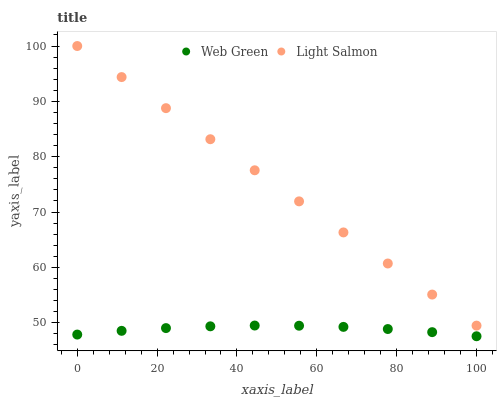Does Web Green have the minimum area under the curve?
Answer yes or no. Yes. Does Light Salmon have the maximum area under the curve?
Answer yes or no. Yes. Does Web Green have the maximum area under the curve?
Answer yes or no. No. Is Light Salmon the smoothest?
Answer yes or no. Yes. Is Web Green the roughest?
Answer yes or no. Yes. Is Web Green the smoothest?
Answer yes or no. No. Does Web Green have the lowest value?
Answer yes or no. Yes. Does Light Salmon have the highest value?
Answer yes or no. Yes. Does Web Green have the highest value?
Answer yes or no. No. Is Web Green less than Light Salmon?
Answer yes or no. Yes. Is Light Salmon greater than Web Green?
Answer yes or no. Yes. Does Web Green intersect Light Salmon?
Answer yes or no. No. 